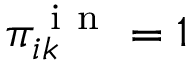Convert formula to latex. <formula><loc_0><loc_0><loc_500><loc_500>\pi _ { i k } ^ { i n } = 1</formula> 